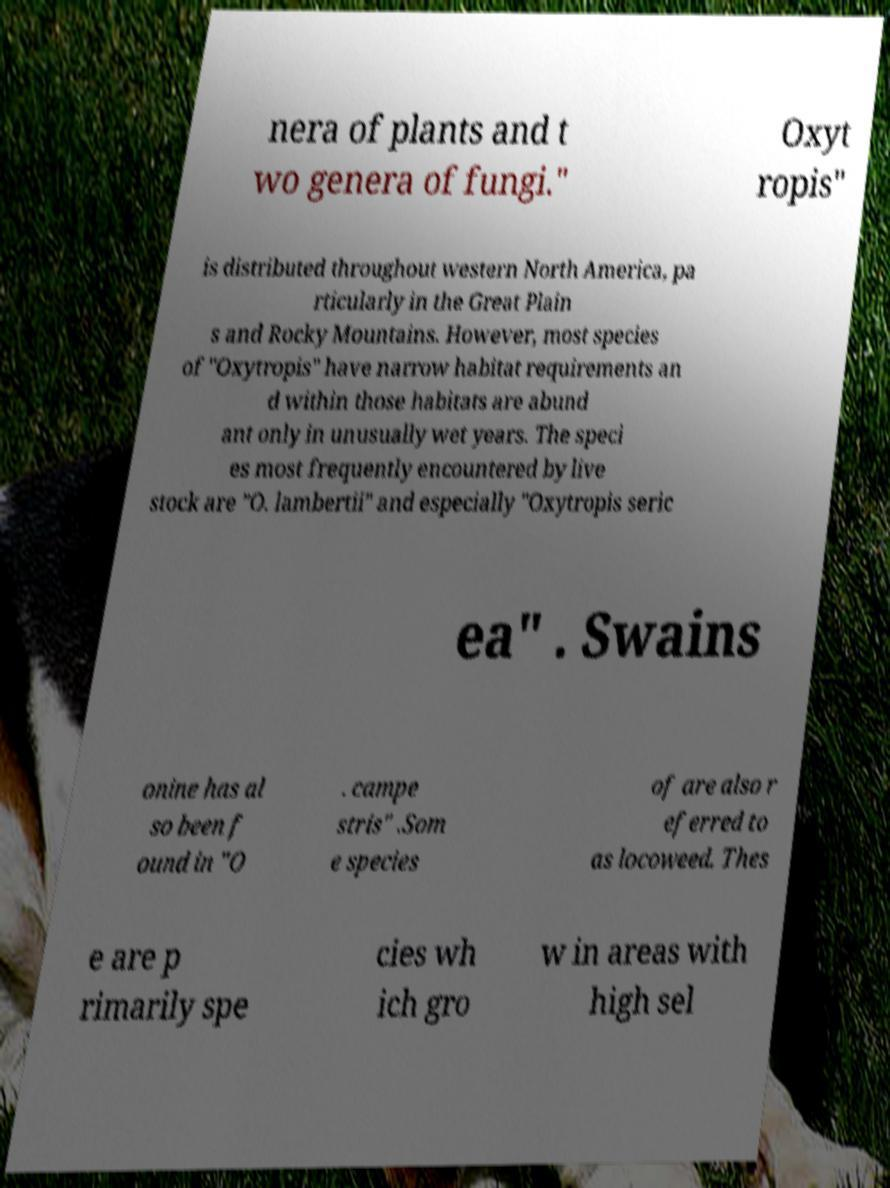Please read and relay the text visible in this image. What does it say? nera of plants and t wo genera of fungi." Oxyt ropis" is distributed throughout western North America, pa rticularly in the Great Plain s and Rocky Mountains. However, most species of "Oxytropis" have narrow habitat requirements an d within those habitats are abund ant only in unusually wet years. The speci es most frequently encountered by live stock are "O. lambertii" and especially "Oxytropis seric ea" . Swains onine has al so been f ound in "O . campe stris" .Som e species of are also r eferred to as locoweed. Thes e are p rimarily spe cies wh ich gro w in areas with high sel 